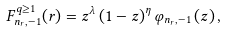Convert formula to latex. <formula><loc_0><loc_0><loc_500><loc_500>F _ { n _ { r } , - 1 } ^ { q \geq 1 } ( r ) = z ^ { \lambda } \left ( 1 - z \right ) ^ { \eta } \varphi _ { n _ { r } , - 1 } \left ( z \right ) ,</formula> 